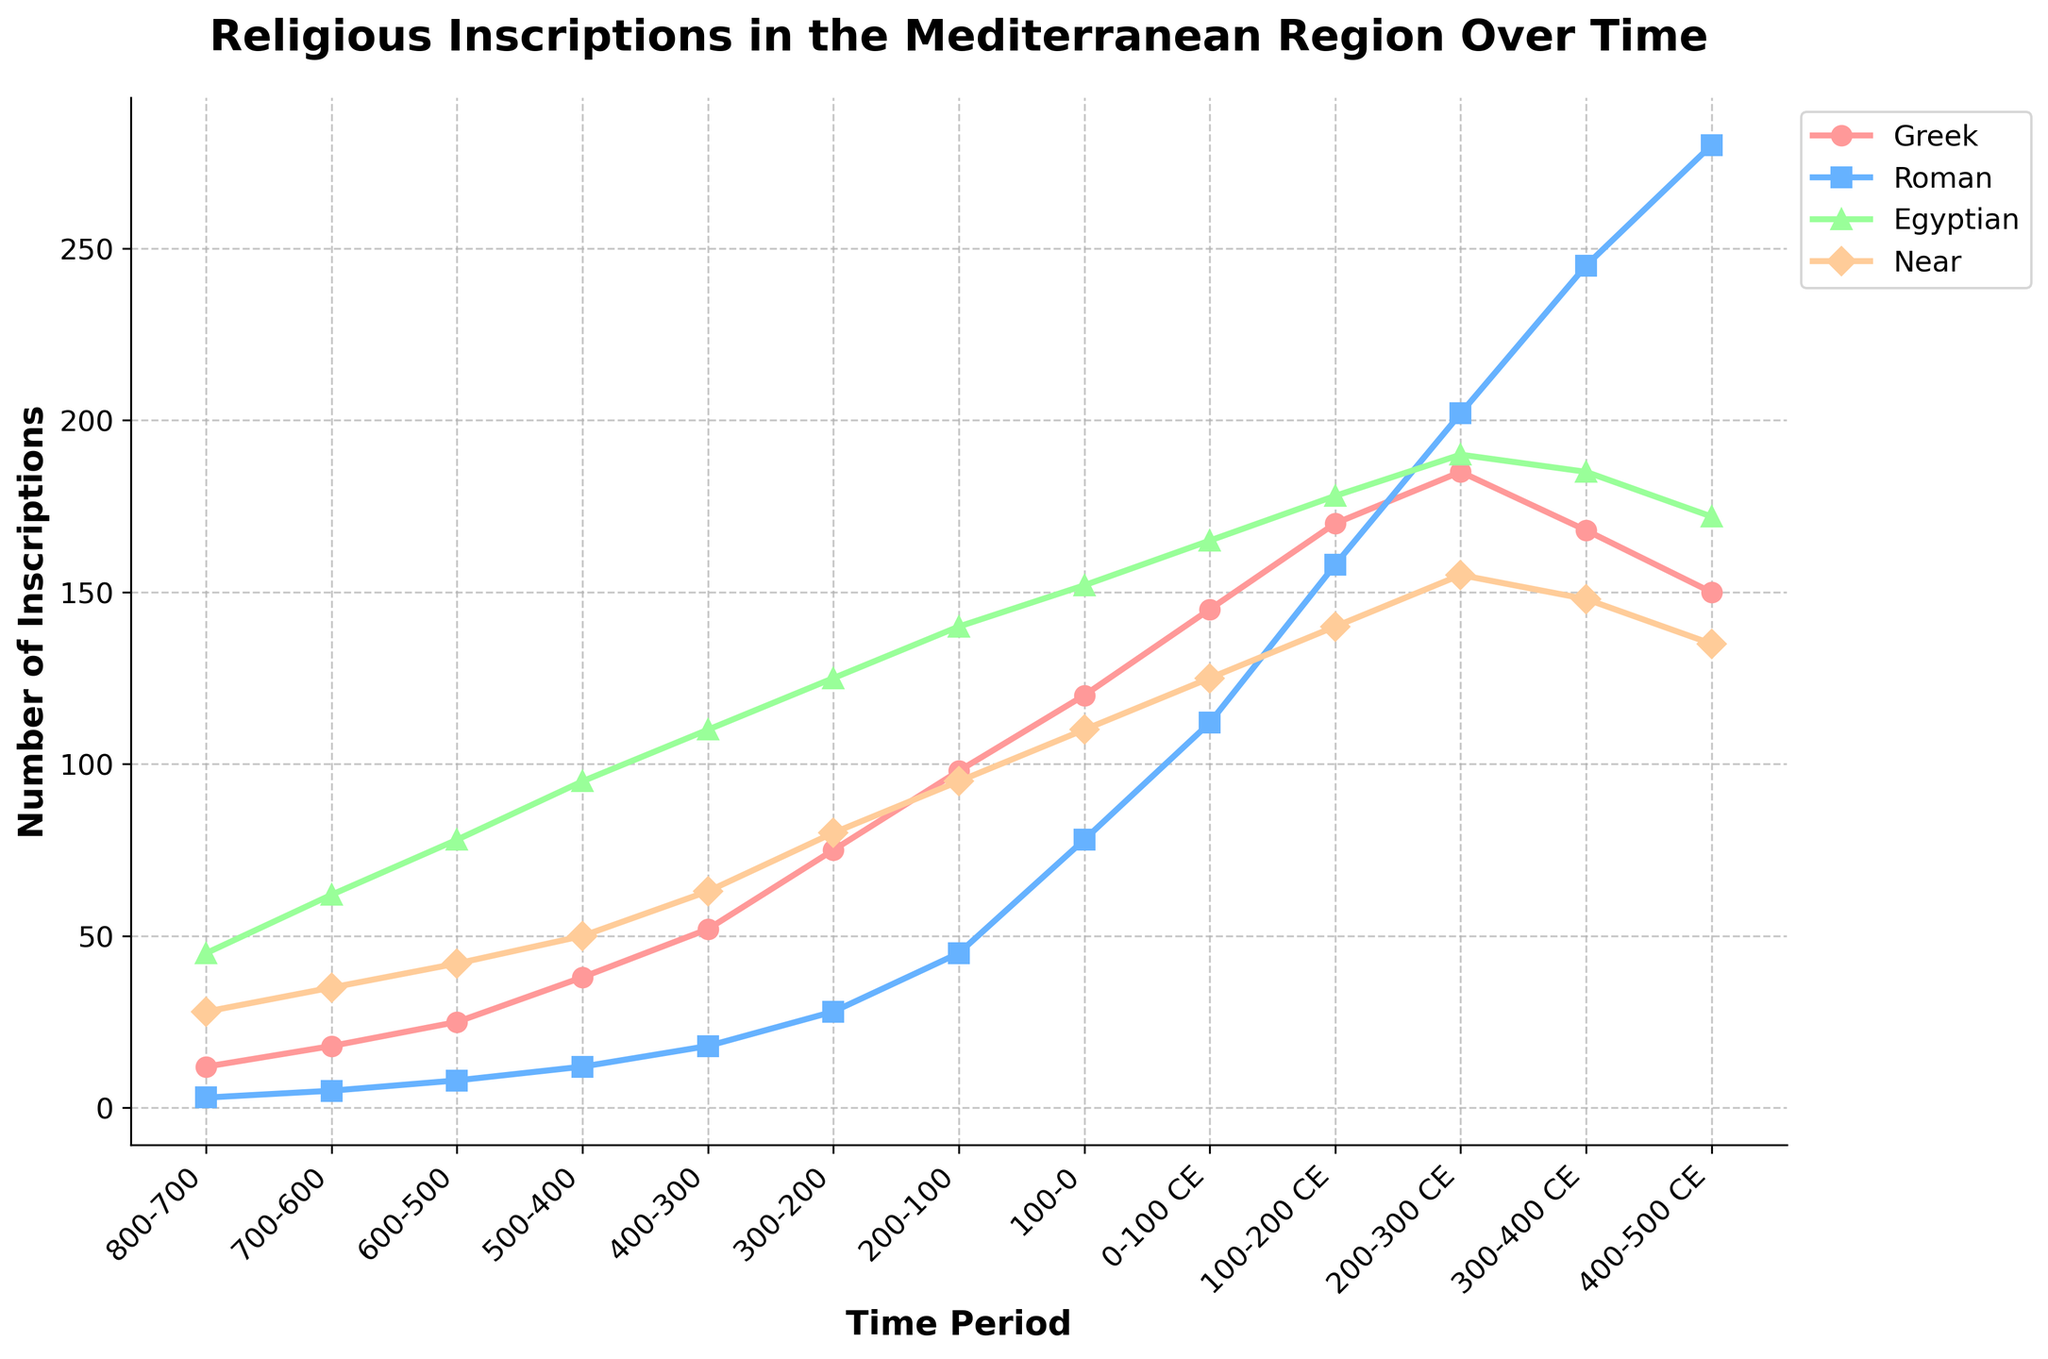What is the time period during which Greek inscriptions were most frequent? The peak frequency of Greek inscriptions occurs at the highest data point in the Greek inscriptions line. The maximum frequency is 185, which occurs during the 200-300 CE time period.
Answer: 200-300 CE How many total Roman inscriptions are there in the 400-500 CE time period? To find the total Roman inscriptions, look at the data point for Roman inscriptions in the 400-500 CE time period. It shows 280 inscriptions.
Answer: 280 During which time period do Near Eastern inscriptions start to decline? The decline in Near Eastern inscriptions begins when the data decreases from one time period to the next. The maximum of 155 occurs in the 200-300 CE time period, drops to 148 in the 300-400 CE period, and continues to decline.
Answer: 200-300 CE Which religious group showed the most rapid increase between 100-200 CE and 200-300 CE? Calculate the differences between the data points for each group in these periods. For Greek, it's 185-170 = 15. For Roman, it's 202-158 = 44. For Egyptian, it's 190-178 = 12. For Near Eastern, it's 155-140 = 15. The highest increase is in Roman inscriptions.
Answer: Roman What is the average number of inscriptions for Egyptian inscriptions in the 600-500 BCE to 400-300 BCE periods? Sum the data points for Egyptian inscriptions in these periods and divide by the number of periods. (78 + 95 + 110) / 3 = 283 / 3 ≈ 94.33
Answer: 94.33 Which religion had the lowest number of inscriptions in the 700-600 BCE period? Compare the data points for each religion in that period. Greek has 18, Roman has 5, Egyptian has 62, and Near Eastern has 35. The lowest number is for Roman inscriptions.
Answer: Roman In which period did Greek inscriptions surpass 100 for the first time? Identify when the data for Greek inscriptions crosses the 100 mark. They reach 120 in the 100-0 BCE period.
Answer: 100-0 BCE Calculate the sum of Near Eastern inscriptions from the 100-0 BCE to the 300-400 CE periods. Sum the data points for Near Eastern inscriptions in these periods: 110 + 125 + 140 + 155 + 148 = 678.
Answer: 678 By how much did the number of Egyptian inscriptions increase from 800-700 BCE to 0-100 CE? Find the difference between the data points for these periods: 165 (0-100 CE) - 45 (800-700 BCE) = 120.
Answer: 120 Which inscriptions decreased in number after the 200-300 CE period? Look for inscriptions that have lower data points in the 300-400 CE period compared to 200-300 CE: Greek (168 < 185), Egyptian (185 < 190), and Near Eastern (148 < 155) all decreased. Only Roman increased.
Answer: Greek, Egyptian, Near Eastern 